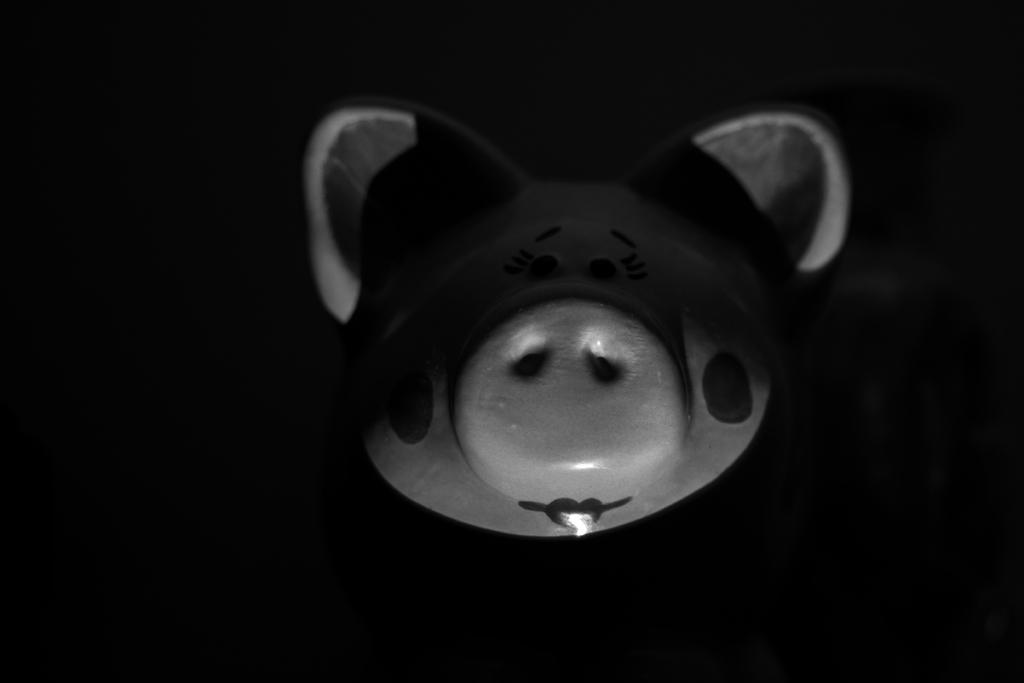What object can be seen in the image? There is a toy in the image. What can be observed about the background of the image? The background of the image is dark. What type of cake is being served at the pie-eating contest in the image? There is no cake or pie-eating contest present in the image; it only features a toy and a dark background. 